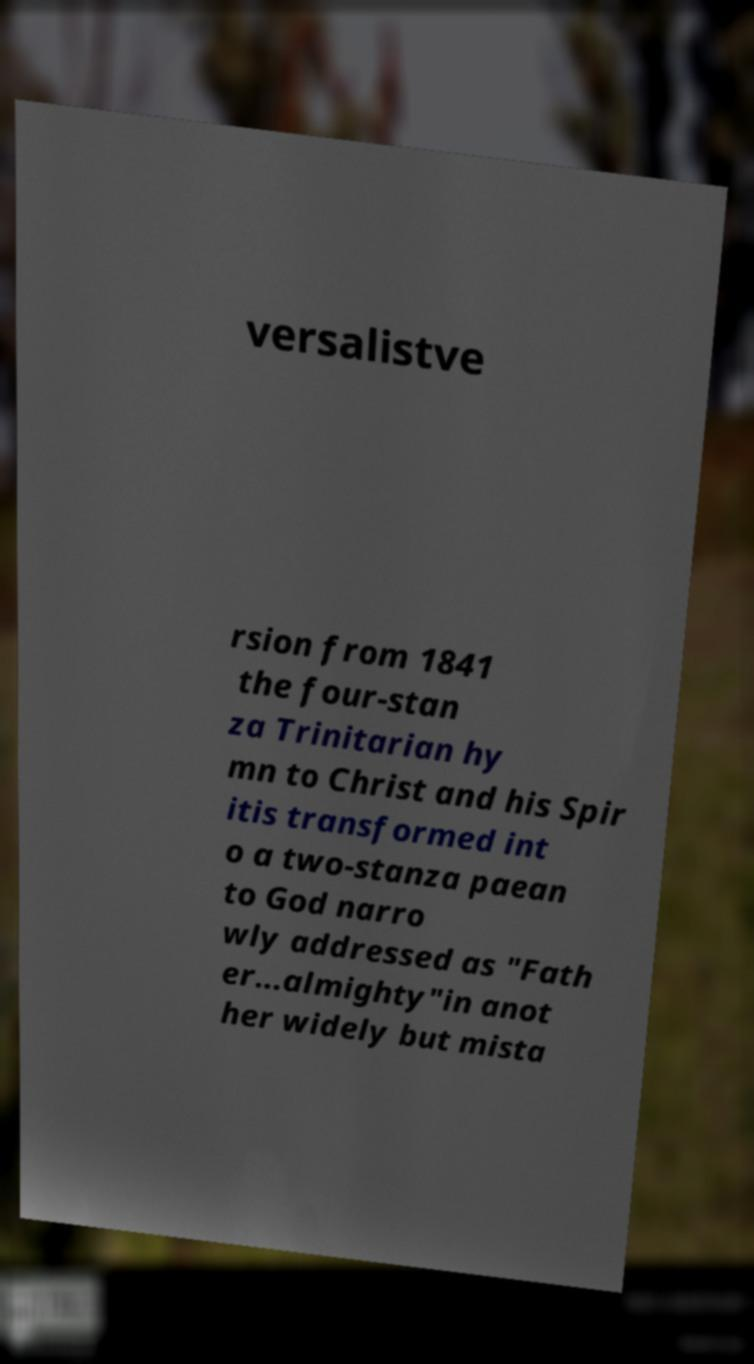Can you read and provide the text displayed in the image?This photo seems to have some interesting text. Can you extract and type it out for me? versalistve rsion from 1841 the four-stan za Trinitarian hy mn to Christ and his Spir itis transformed int o a two-stanza paean to God narro wly addressed as "Fath er...almighty"in anot her widely but mista 